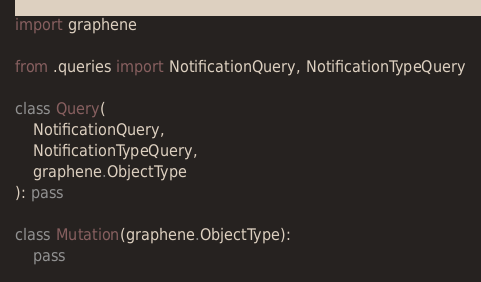<code> <loc_0><loc_0><loc_500><loc_500><_Python_>import graphene

from .queries import NotificationQuery, NotificationTypeQuery

class Query(
    NotificationQuery,
    NotificationTypeQuery,
    graphene.ObjectType
): pass

class Mutation(graphene.ObjectType):
    pass
</code> 